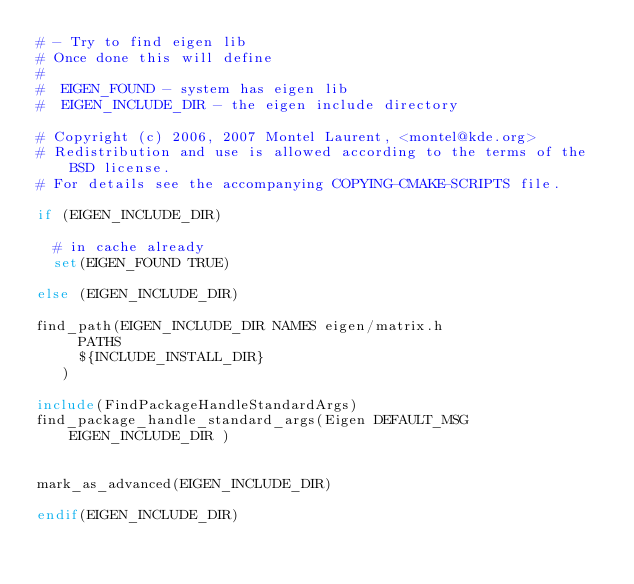<code> <loc_0><loc_0><loc_500><loc_500><_CMake_># - Try to find eigen lib
# Once done this will define
#
#  EIGEN_FOUND - system has eigen lib
#  EIGEN_INCLUDE_DIR - the eigen include directory

# Copyright (c) 2006, 2007 Montel Laurent, <montel@kde.org>
# Redistribution and use is allowed according to the terms of the BSD license.
# For details see the accompanying COPYING-CMAKE-SCRIPTS file.

if (EIGEN_INCLUDE_DIR)

  # in cache already
  set(EIGEN_FOUND TRUE)

else (EIGEN_INCLUDE_DIR)

find_path(EIGEN_INCLUDE_DIR NAMES eigen/matrix.h
     PATHS
     ${INCLUDE_INSTALL_DIR}
   )

include(FindPackageHandleStandardArgs)
find_package_handle_standard_args(Eigen DEFAULT_MSG EIGEN_INCLUDE_DIR )


mark_as_advanced(EIGEN_INCLUDE_DIR)

endif(EIGEN_INCLUDE_DIR)

</code> 